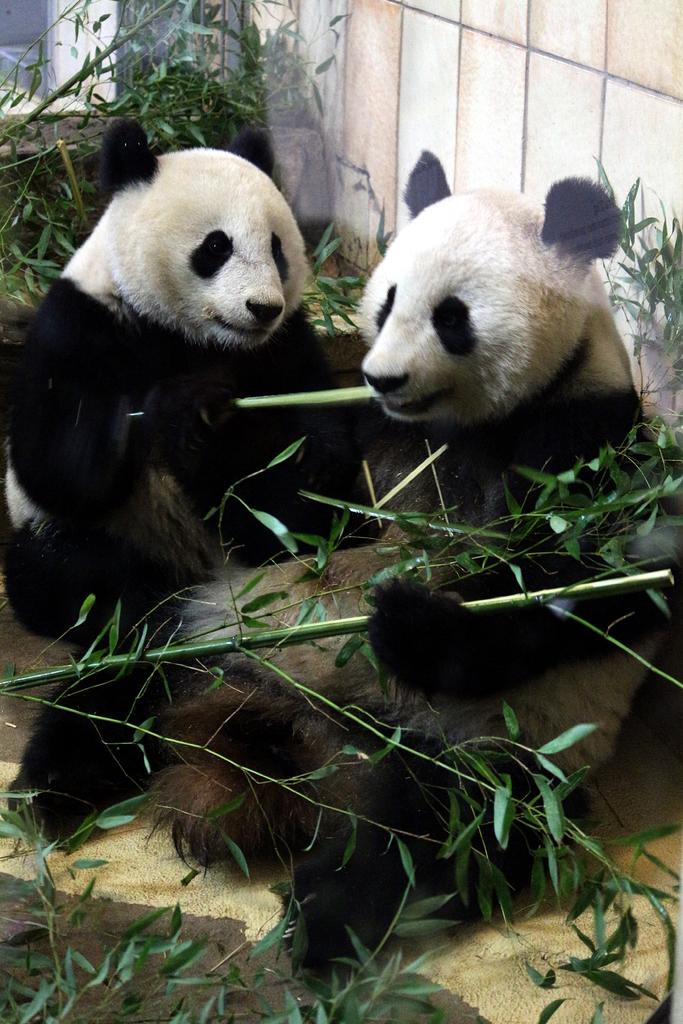What animals are present in the image? There are two pandas in the image. What are the pandas doing in the image? The pandas are sitting. What can be seen in the background of the image? There is a wall in the image. What type of vegetation is visible in the image? There are plants in the image. What type of oatmeal is being served at the market in the image? There is no market or oatmeal present in the image; it features two pandas sitting and a wall with plants. How many beds are visible in the image? There are no beds visible in the image; it features two pandas sitting and a wall with plants. 